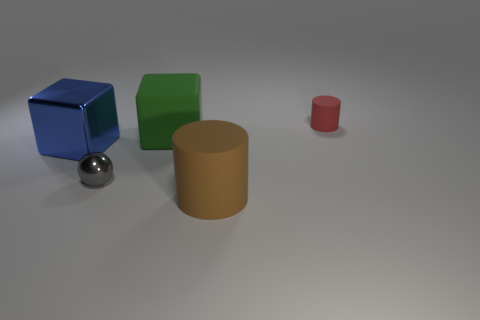Are there any other things that are the same shape as the gray thing?
Provide a succinct answer. No. What number of things are either matte objects that are to the left of the brown object or small green shiny things?
Your response must be concise. 1. There is a rubber thing that is both in front of the tiny red object and behind the large metal thing; what is its size?
Give a very brief answer. Large. What number of other objects are the same size as the blue metallic block?
Ensure brevity in your answer.  2. There is a large object left of the green matte block in front of the small thing behind the large rubber cube; what is its color?
Your answer should be compact. Blue. What is the shape of the rubber thing that is both on the right side of the green cube and behind the large blue shiny object?
Offer a very short reply. Cylinder. How many other things are the same shape as the red rubber object?
Offer a terse response. 1. There is a matte object that is right of the matte cylinder in front of the matte cylinder that is on the right side of the large brown matte cylinder; what is its shape?
Your answer should be compact. Cylinder. How many objects are blue metal objects or rubber cylinders on the left side of the red rubber object?
Offer a terse response. 2. Is the shape of the green matte thing that is in front of the tiny red cylinder the same as the shiny thing behind the sphere?
Your response must be concise. Yes. 